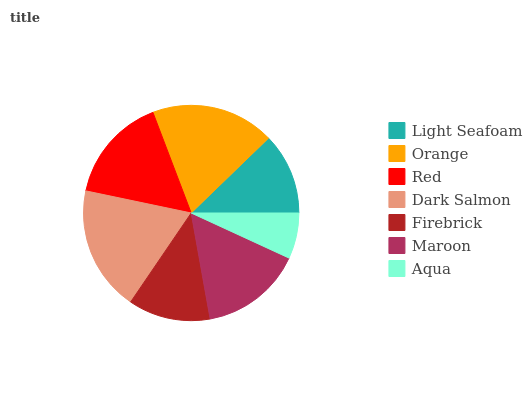Is Aqua the minimum?
Answer yes or no. Yes. Is Dark Salmon the maximum?
Answer yes or no. Yes. Is Orange the minimum?
Answer yes or no. No. Is Orange the maximum?
Answer yes or no. No. Is Orange greater than Light Seafoam?
Answer yes or no. Yes. Is Light Seafoam less than Orange?
Answer yes or no. Yes. Is Light Seafoam greater than Orange?
Answer yes or no. No. Is Orange less than Light Seafoam?
Answer yes or no. No. Is Maroon the high median?
Answer yes or no. Yes. Is Maroon the low median?
Answer yes or no. Yes. Is Aqua the high median?
Answer yes or no. No. Is Red the low median?
Answer yes or no. No. 